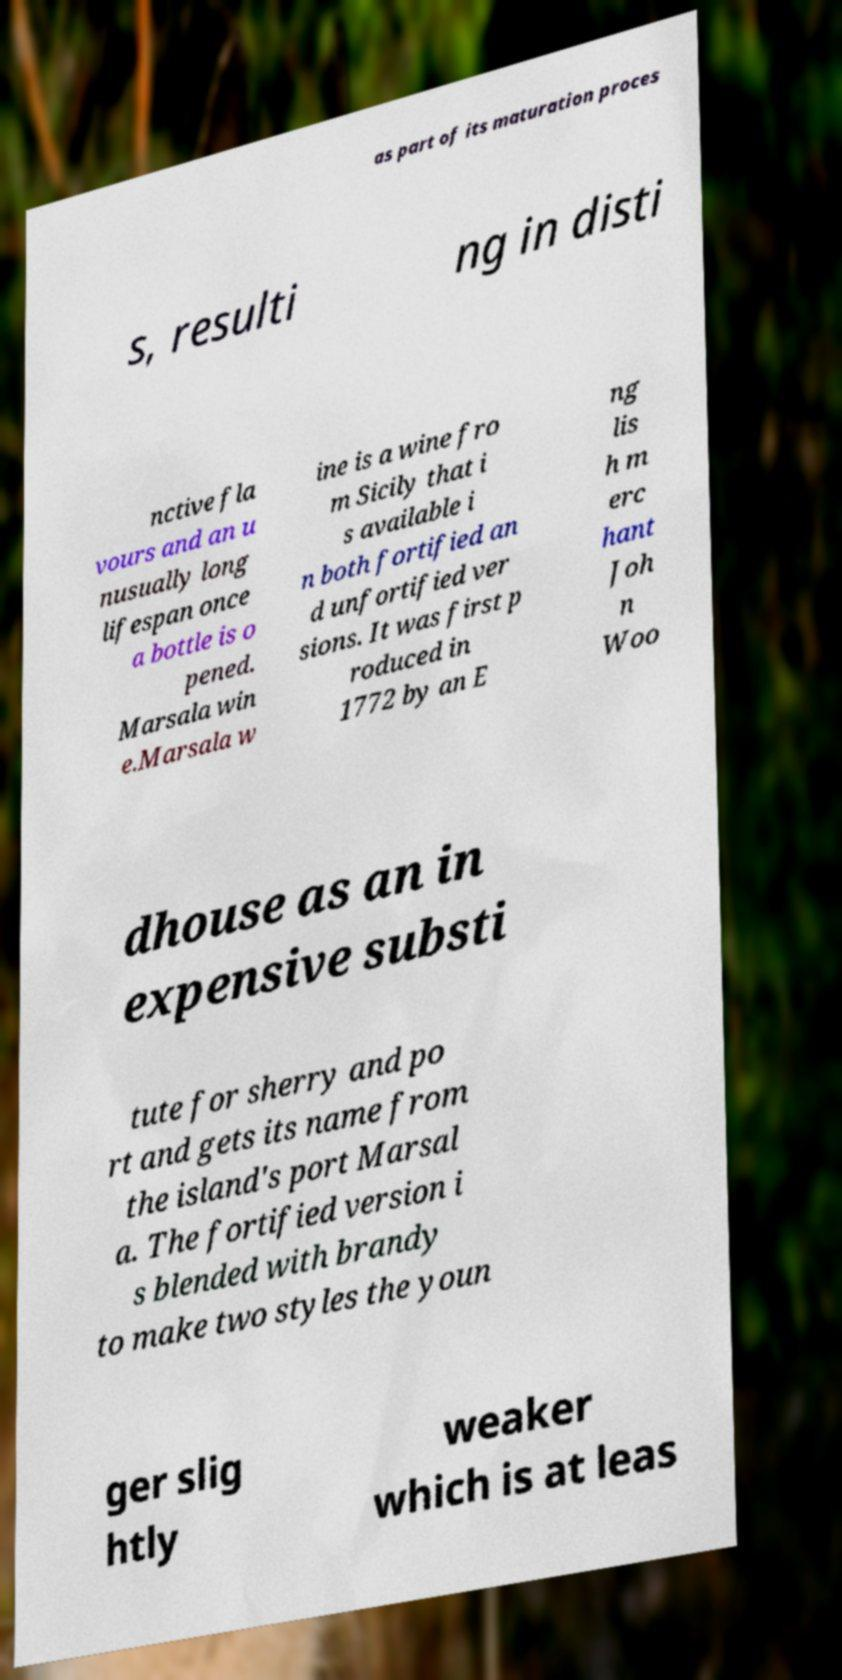I need the written content from this picture converted into text. Can you do that? as part of its maturation proces s, resulti ng in disti nctive fla vours and an u nusually long lifespan once a bottle is o pened. Marsala win e.Marsala w ine is a wine fro m Sicily that i s available i n both fortified an d unfortified ver sions. It was first p roduced in 1772 by an E ng lis h m erc hant Joh n Woo dhouse as an in expensive substi tute for sherry and po rt and gets its name from the island's port Marsal a. The fortified version i s blended with brandy to make two styles the youn ger slig htly weaker which is at leas 